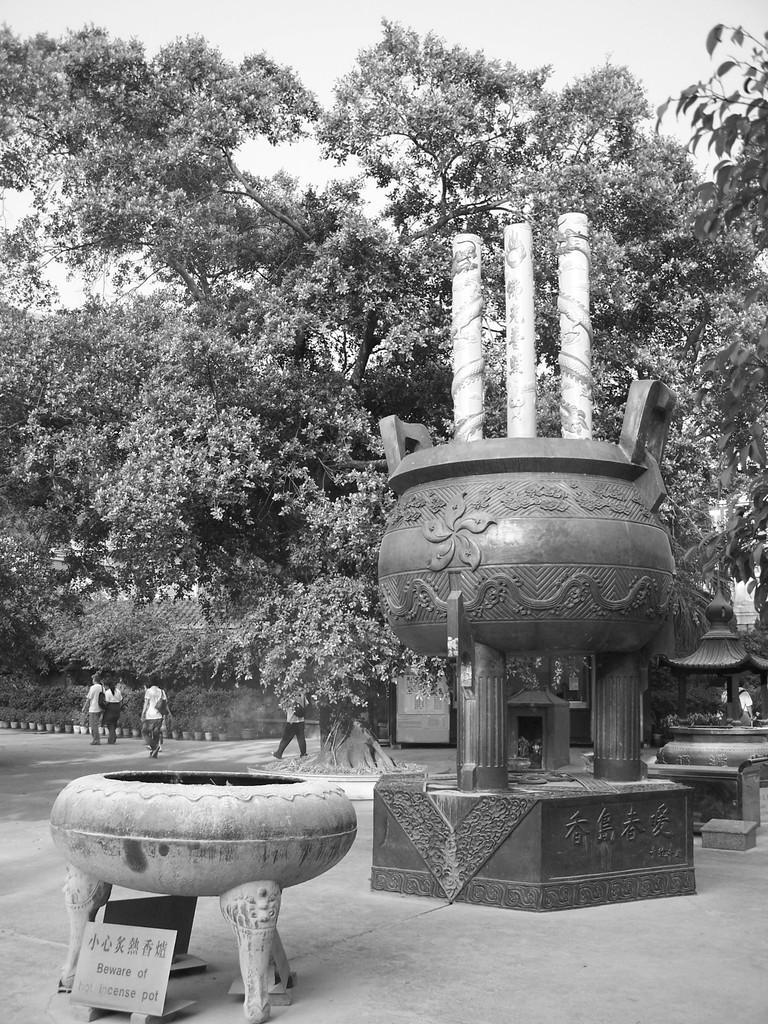Describe this image in one or two sentences. In this picture we can see statues, information board, trees and some people and in the background we can see the sky. 